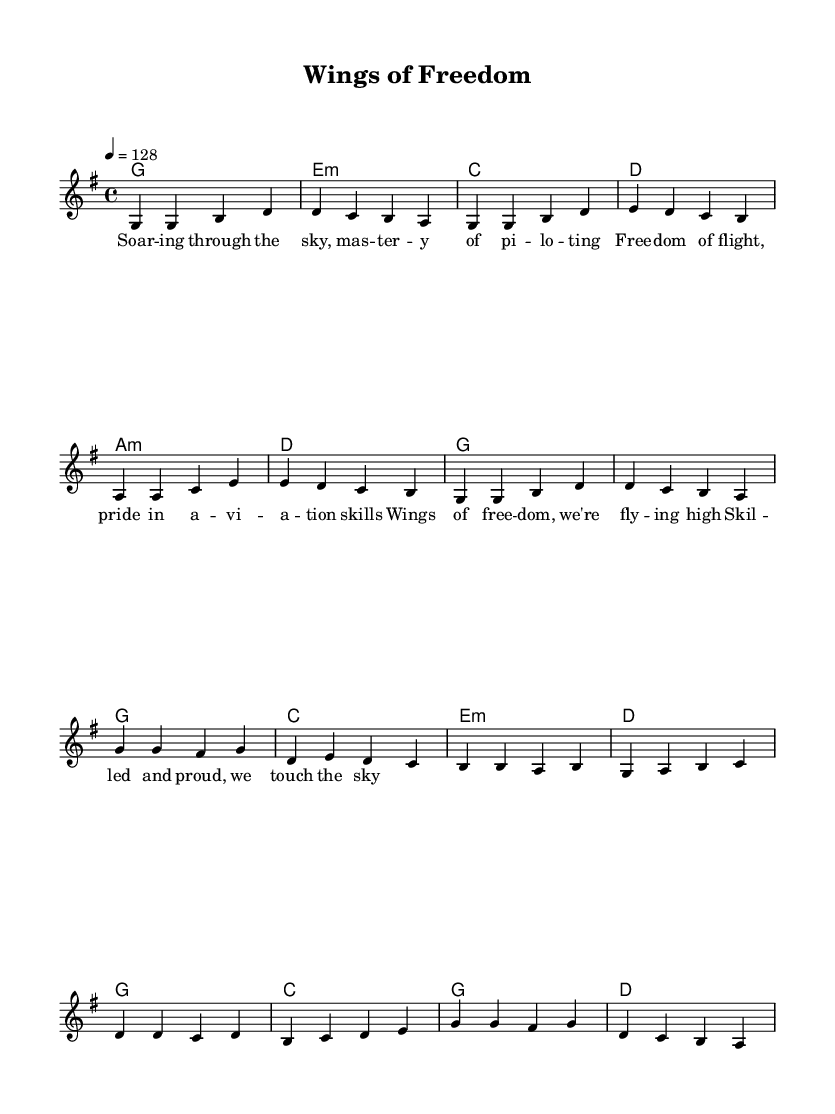What is the key signature of this music? The key signature is G major, which has one sharp (F#). You can determine this by observing the key signature at the beginning of the staff where the note F has a sharp indicating G major.
Answer: G major What is the time signature of this music? The time signature shown at the beginning of the score is 4/4, which means there are four beats per measure and the quarter note gets one beat. This is indicated by the fraction present at the start of the sheet music.
Answer: 4/4 What is the tempo marking for this piece? The tempo marking indicates a speed of 128 beats per minute, as written in the tempo section above the staff. This means the music should be played at a lively pace.
Answer: 128 How many measures are there in the chorus? The chorus section consists of eight measures, which can be counted by segmenting the musical notes and chords, labeled from the start of the chorus to its end.
Answer: Eight What kind of lyrics are being presented in this K-Pop track? The lyrics celebrate flying and piloting skills, as indicated by phrases like "Soaring through the sky" and "Wings of freedom." This thematic element is typical for K-Pop songs that evoke uplifting imagery and emotions.
Answer: Celebration of flying Which chord is used in the last measure of the verse? The last measure of the verse contains a G chord, as indicated by the chord symbol written above that specific measure in the harmony section.
Answer: G 